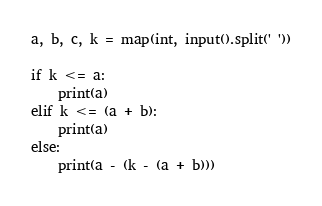<code> <loc_0><loc_0><loc_500><loc_500><_Python_>a, b, c, k = map(int, input().split(' '))

if k <= a:
    print(a)
elif k <= (a + b):
    print(a)
else:
    print(a - (k - (a + b)))</code> 